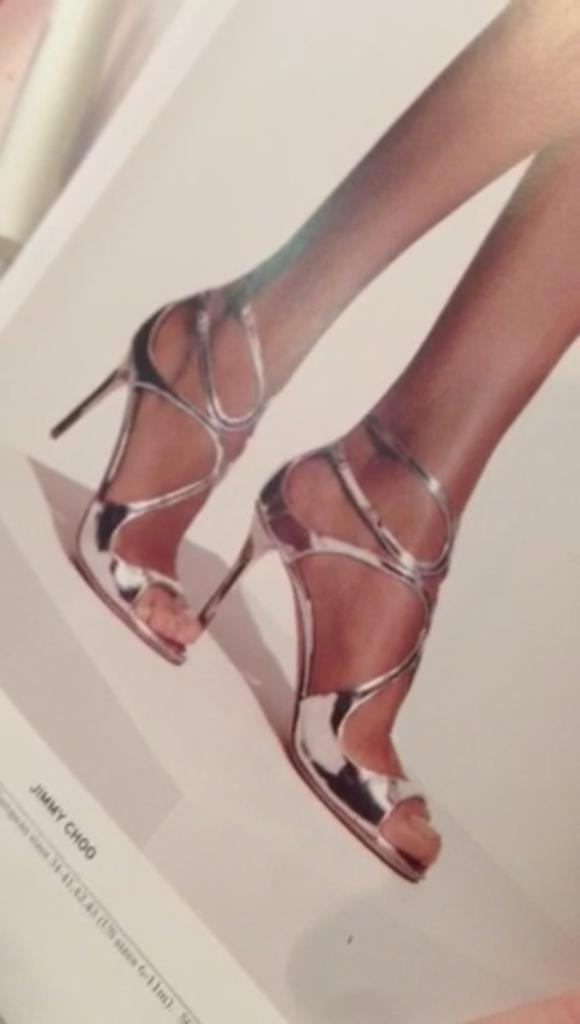What is present on the paper in the image? The paper contains an image of a person's legs. Are there any other elements on the paper besides the image? Yes, there is text on the paper. How many giraffes can be seen in the image? There are no giraffes present in the image. What type of bushes are surrounding the person in the image? There is no person or bushes present in the image; it only contains a paper with an image of a person's legs and text. 